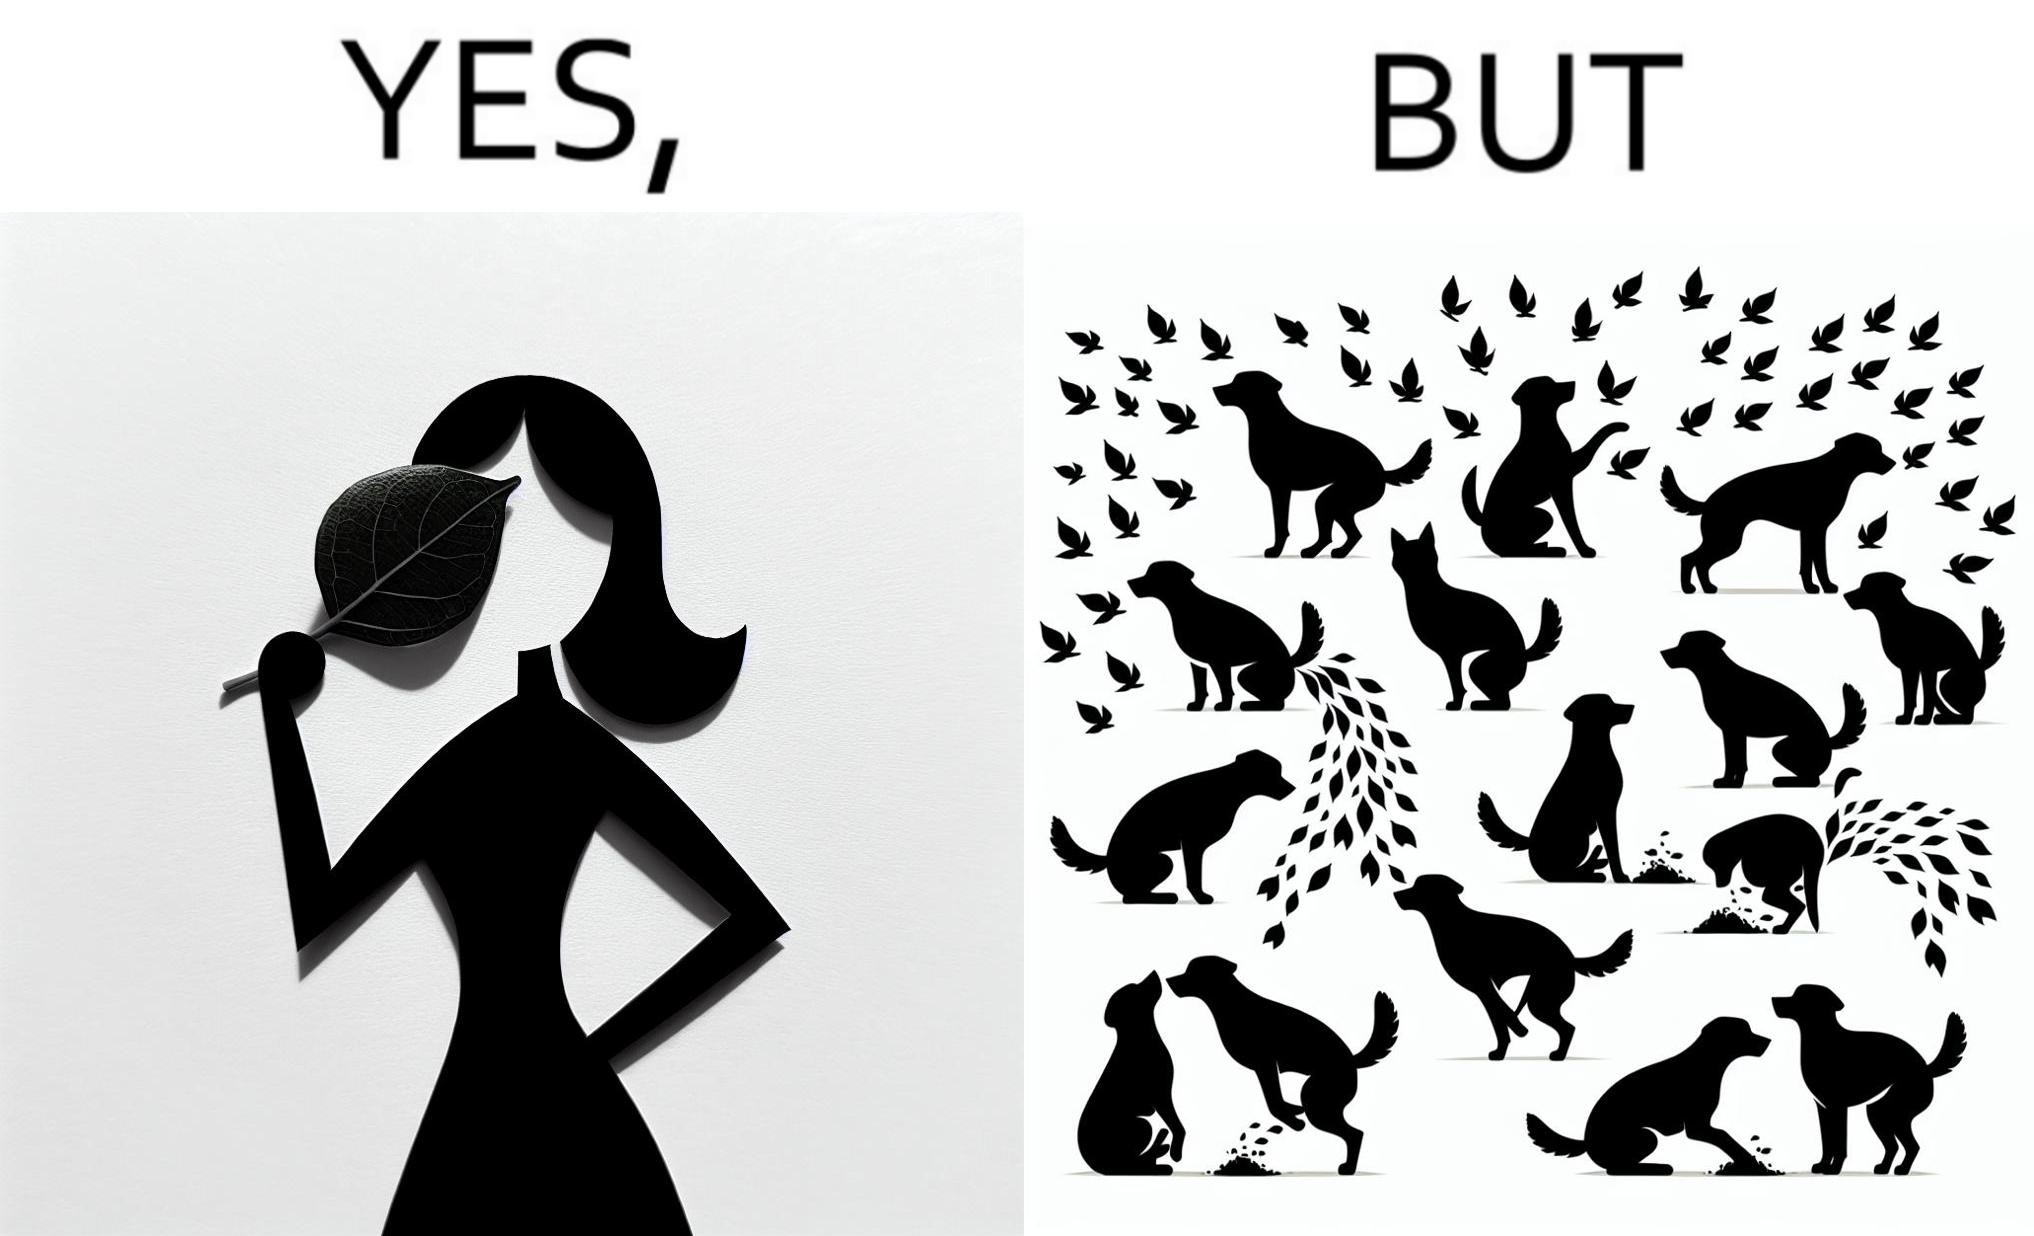What is shown in this image? The images are funny since it show a woman holding a leaf over half of her face for a good photo but unknown to her is thale fact the same leaf might have been defecated or urinated upon by dogs and other wild animals 